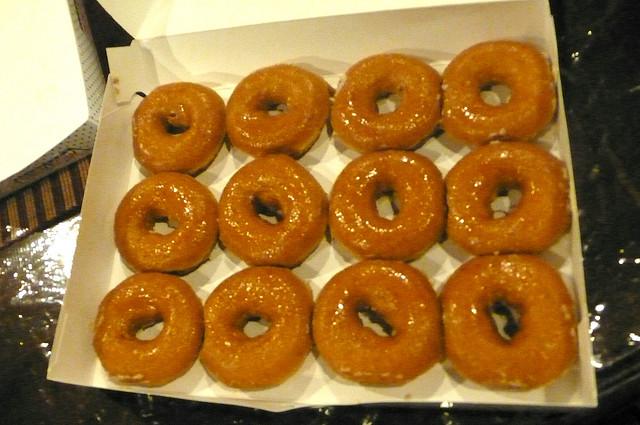Are all donuts the same?
Answer briefly. Yes. Is this a dozen of jelly filled donuts?
Concise answer only. No. How many donuts are there?
Quick response, please. 12. How many donuts are pictured?
Answer briefly. 12. 